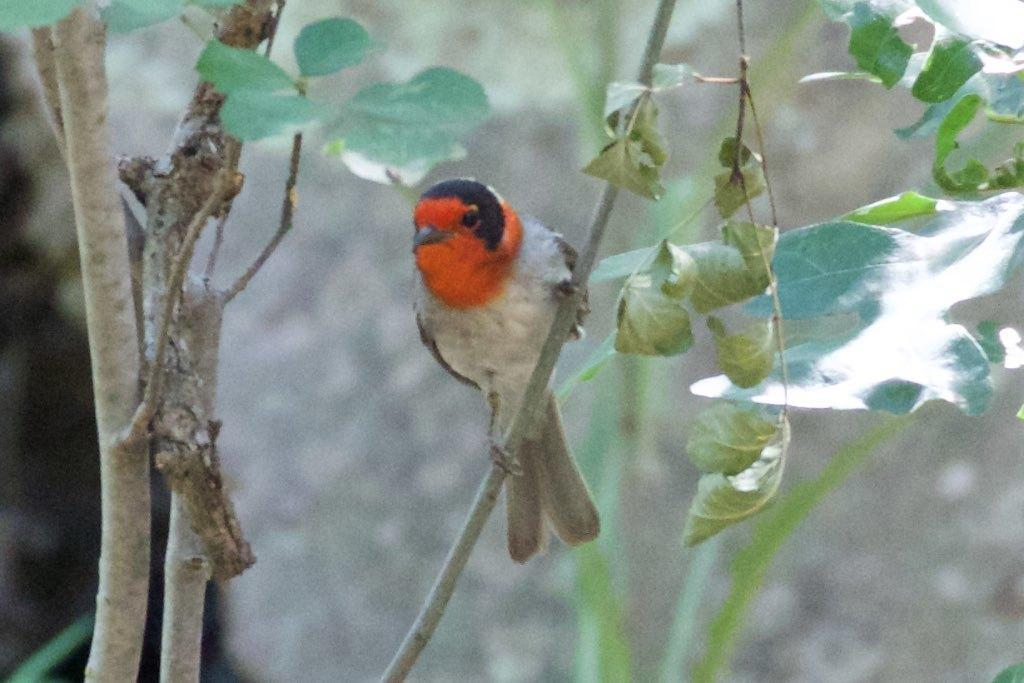What is on the tree stem in the image? There is a bird on the tree stem in the image. What type of vegetation can be seen in the image? Leaves and branches are visible in the image. What part of the tree is observable in the image? Tree stems are observable in the image. How would you describe the background of the image? The background has a blurred view. What type of cattle can be seen grazing in the image? There is no cattle present in the image; it features a bird on a tree stem. What type of structure is visible in the background of the image? There is no structure visible in the background of the image; it has a blurred view. 